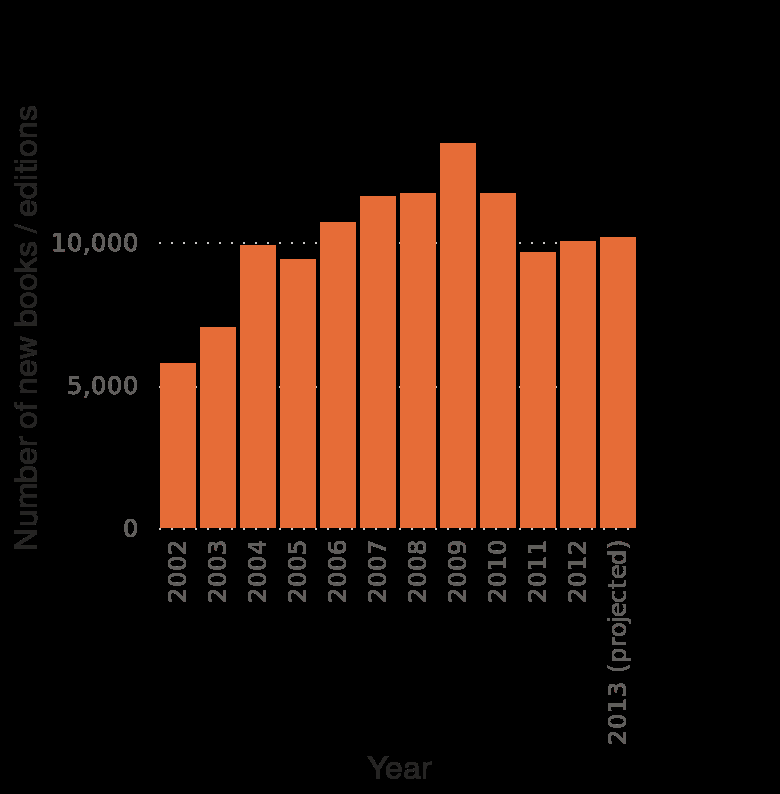<image>
What is the category of books included in the bar plot? The category of books included in the bar plot is poetry/drama. Has the overall number of book publications increased or decreased since 2002?  The overall number of book publications has increased since 2002. What is being plotted in the bar plot? The bar plot is plotting the number of new books and editions published in the United States in the category 'poetry/drama' over the years. Is the line graph plotting the number of old books and editions published in the United States in the category 'poetry/drama' over the years? No.The bar plot is plotting the number of new books and editions published in the United States in the category 'poetry/drama' over the years. 